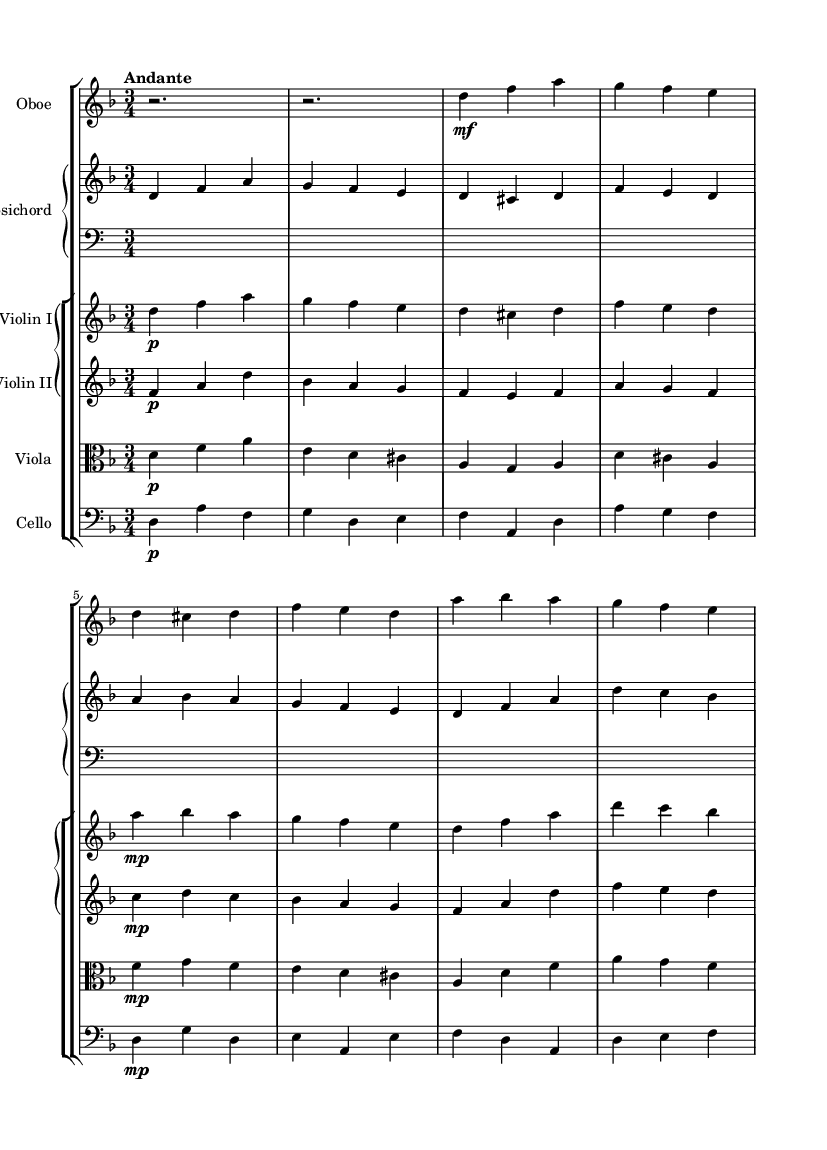What is the key signature of this music? The key signature is indicated at the beginning of the staff, showing two flats, which corresponds to the key of D minor.
Answer: D minor What is the tempo marking for this composition? The tempo marking is found at the beginning of the score, indicating "Andante," which means a moderately slow tempo.
Answer: Andante How many beats are there in a measure? The time signature appears at the beginning of the score, showing 3/4, indicating that there are three beats in each measure.
Answer: 3 Which instrument plays the highest part in this piece? By analyzing the vertical positions of the notes, it is clear that the Violin I part is written significantly higher than the others, making it the highest instrument.
Answer: Violin I What is the dynamic marking for the oboe part at the start of measure 3? The dynamic marking is written above the oboe part, specifying "mf" which stands for mezzo-forte, indicating a moderate volume.
Answer: mezzo-forte What is the relationship between the harpsichord and the cello parts? Upon examining both parts, we can see that they often play complementary or supporting roles, where the harpsichord typically plays chords, and the cello plays the bass line. This indicates a typical Baroque texture.
Answer: Complementary roles How does the piece incorporate elements of Baroque style? The composition utilizes ornamentation in the violin parts and contrasts in texture, typical features of Baroque music, showcasing characteristics such as counterpoint and use of a continuo.
Answer: Ornamentation and counterpoint 